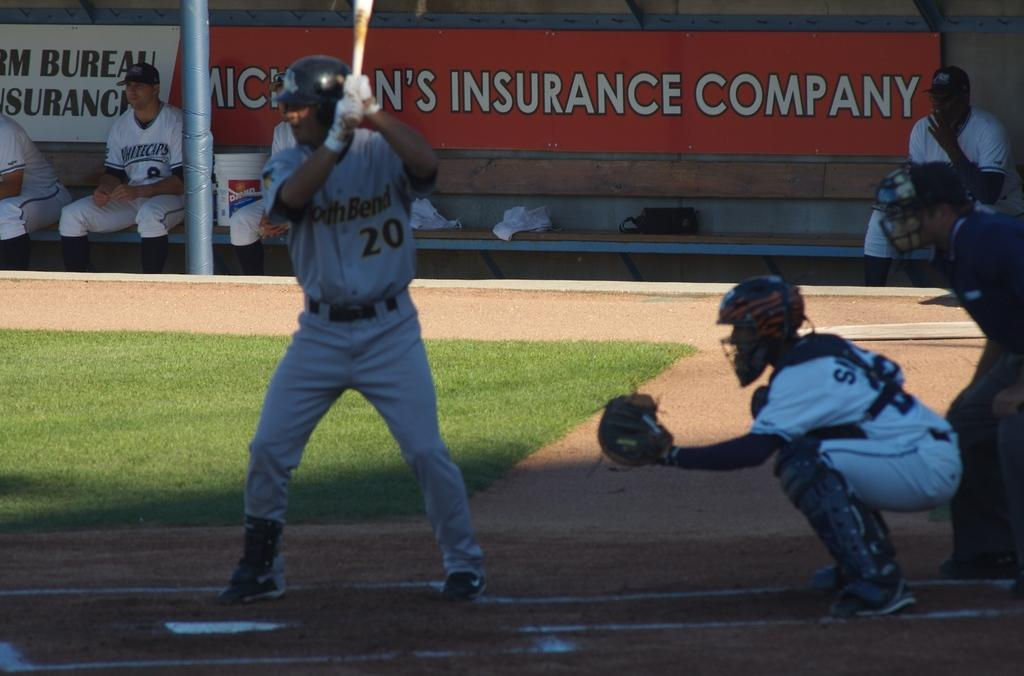<image>
Give a short and clear explanation of the subsequent image. the batter and umpire of a baseball team in front of a sign of Michigan's Insurance Company 